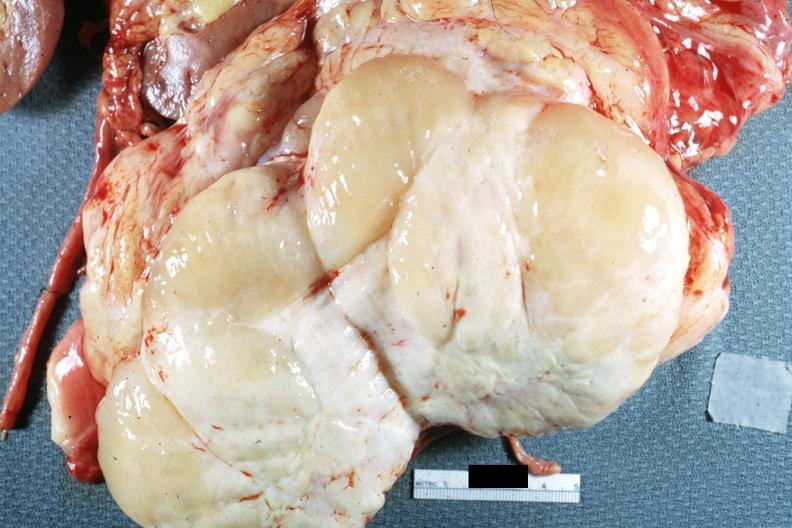s peritoneum present?
Answer the question using a single word or phrase. Yes 